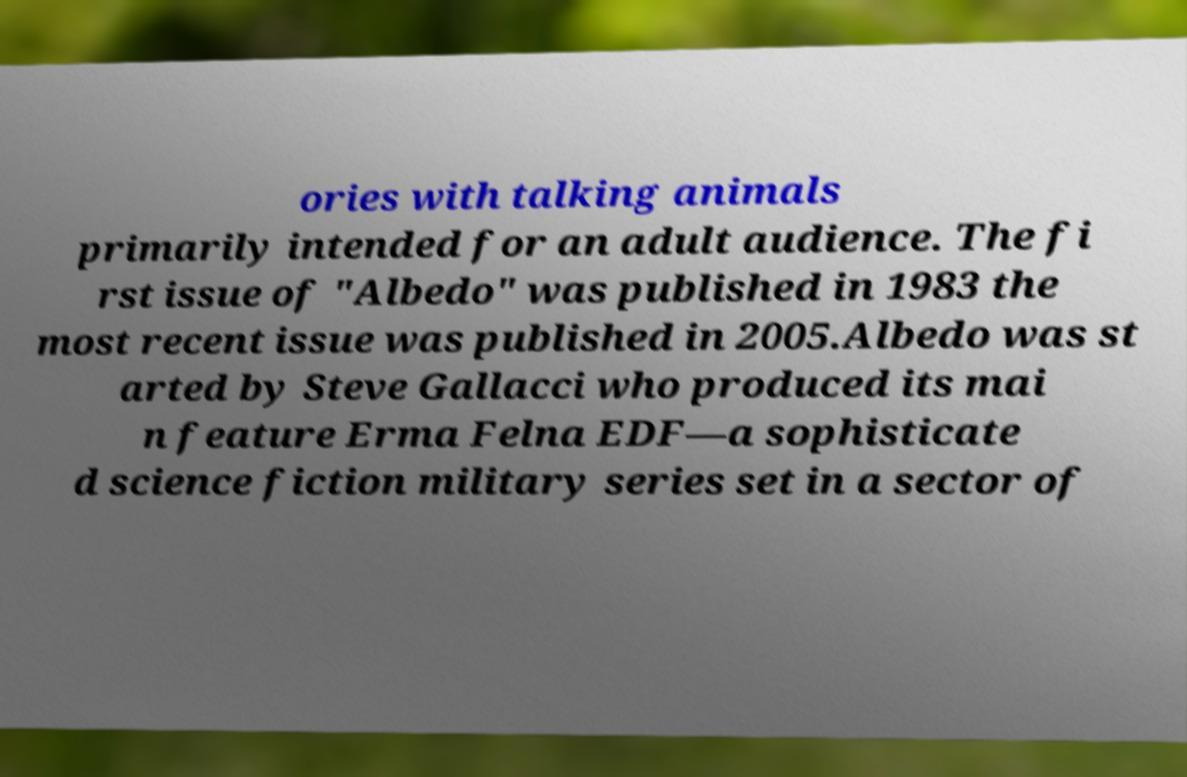Please read and relay the text visible in this image. What does it say? ories with talking animals primarily intended for an adult audience. The fi rst issue of "Albedo" was published in 1983 the most recent issue was published in 2005.Albedo was st arted by Steve Gallacci who produced its mai n feature Erma Felna EDF—a sophisticate d science fiction military series set in a sector of 